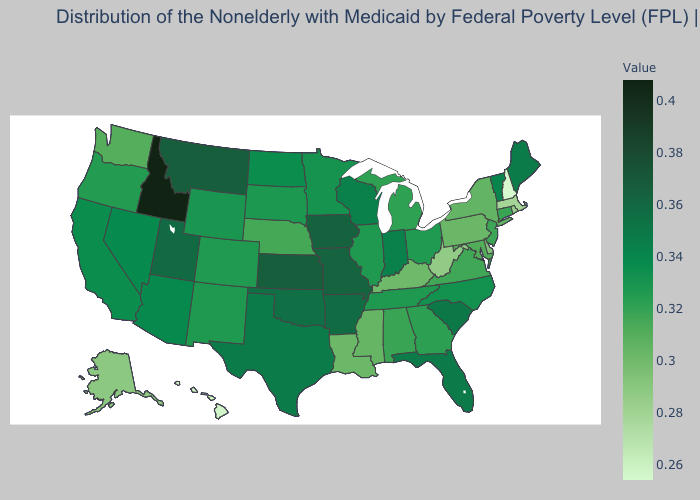Does New Hampshire have the lowest value in the USA?
Write a very short answer. Yes. Which states hav the highest value in the South?
Short answer required. Arkansas. Is the legend a continuous bar?
Be succinct. Yes. Which states have the lowest value in the Northeast?
Quick response, please. New Hampshire. Does Idaho have the highest value in the USA?
Short answer required. Yes. Does Idaho have the highest value in the USA?
Concise answer only. Yes. 